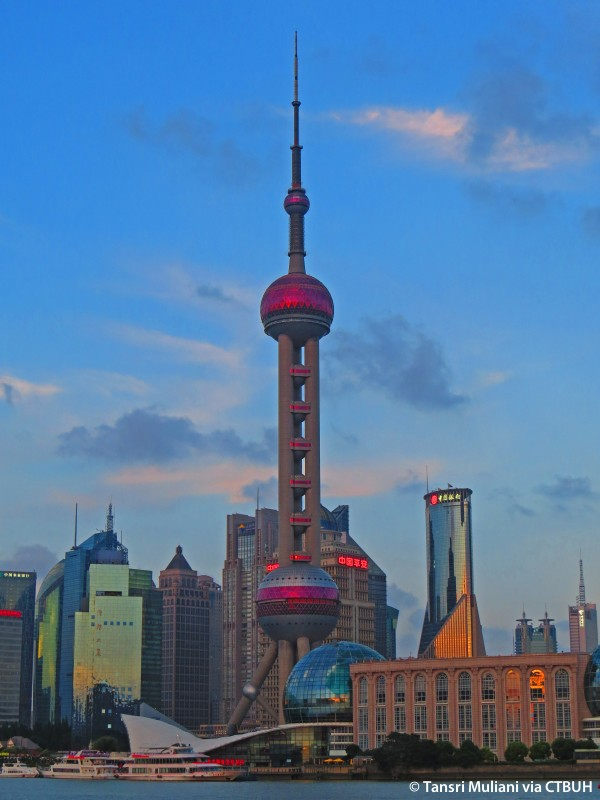What do you see happening in this image? The image captures the Oriental Pearl Tower, a renowned landmark in Shanghai, China. The tower, a strikingly tall and futuristic structure, features a distinctive pink and red color scheme. It stands amidst a skyline brimming with modern skyscrapers, asserting its presence in the cityscape. The photograph is taken from a low angle, enhancing the tower's towering stature and offering a unique perspective of the surrounding skyline. The sky above is a clear blue, dotted with wispy clouds, providing a stunning backdrop to this architectural marvel. In the foreground, a river with a boat is visible, adding to the bustling urban atmosphere. 